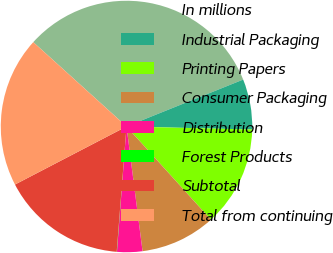Convert chart to OTSL. <chart><loc_0><loc_0><loc_500><loc_500><pie_chart><fcel>In millions<fcel>Industrial Packaging<fcel>Printing Papers<fcel>Consumer Packaging<fcel>Distribution<fcel>Forest Products<fcel>Subtotal<fcel>Total from continuing<nl><fcel>32.21%<fcel>6.47%<fcel>12.9%<fcel>9.68%<fcel>3.25%<fcel>0.03%<fcel>16.12%<fcel>19.34%<nl></chart> 